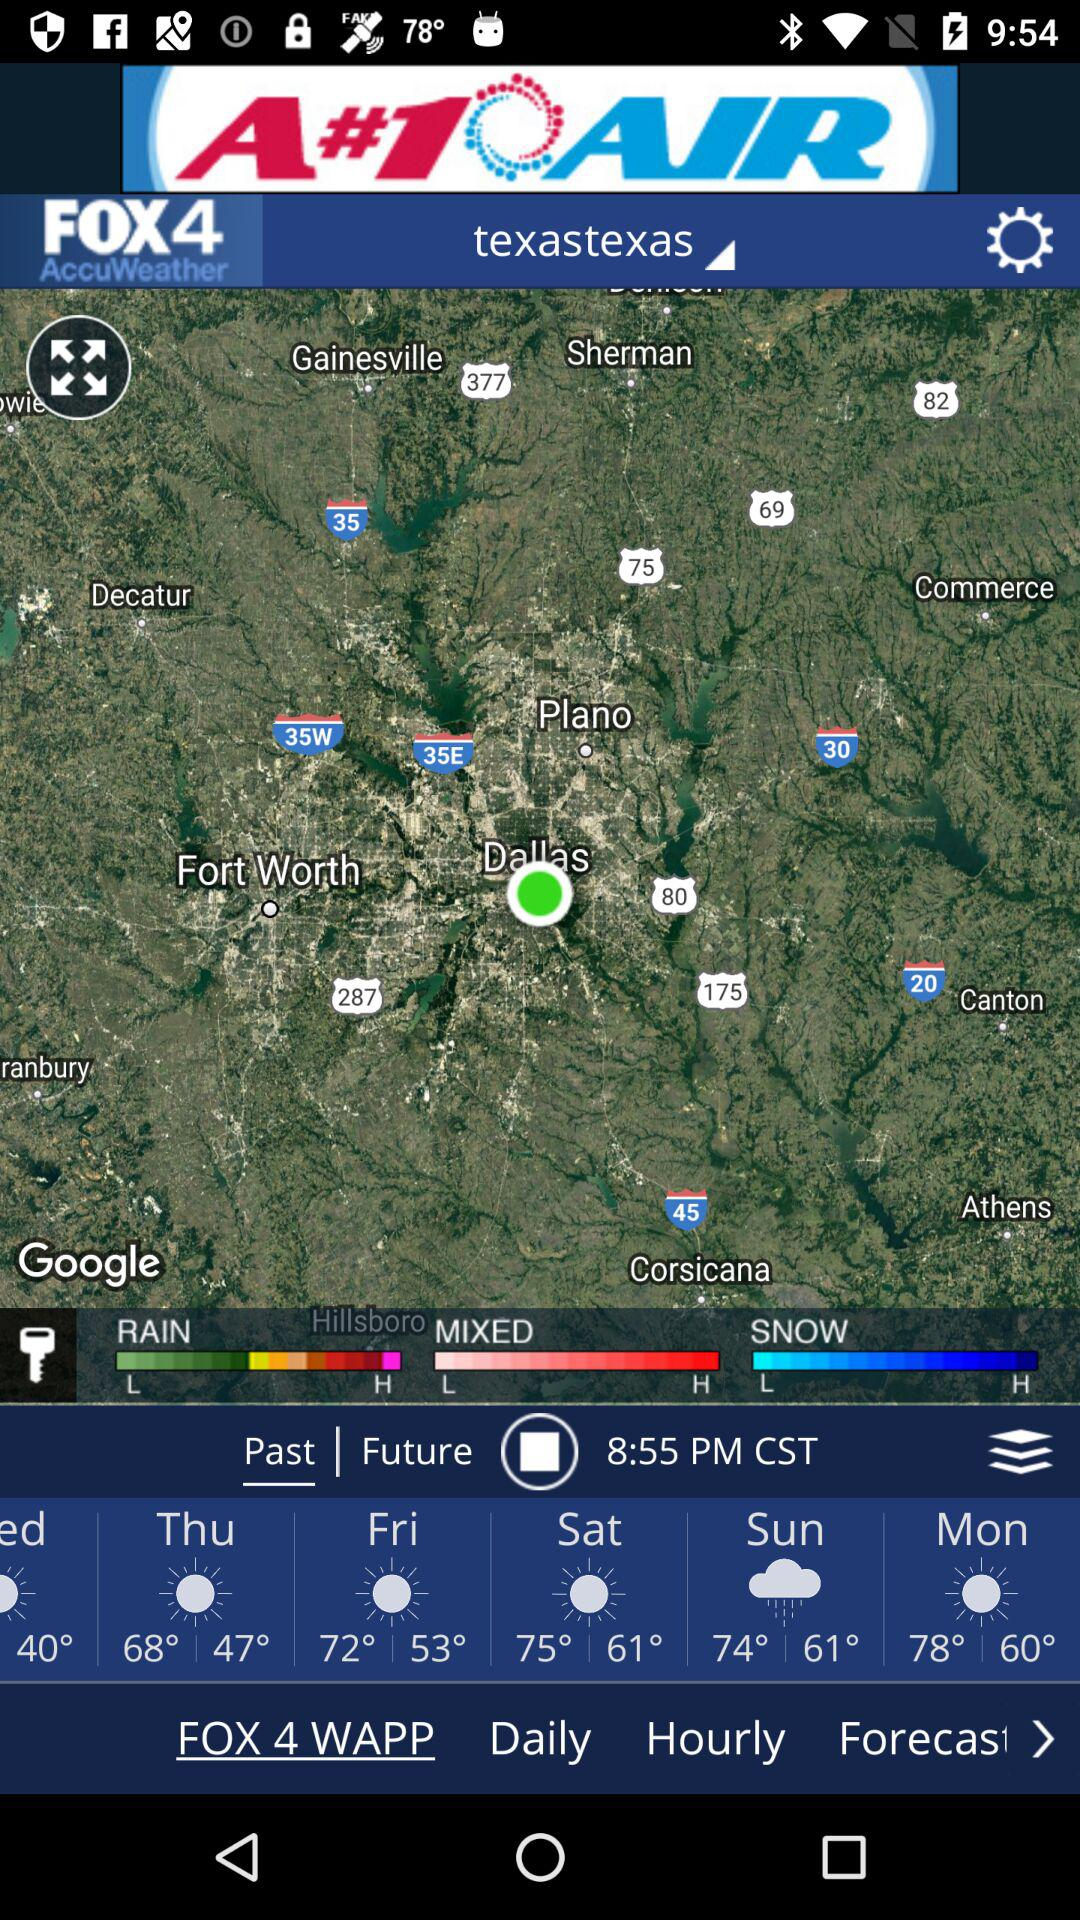How many degrees warmer is it on Saturday than Friday?
Answer the question using a single word or phrase. 3 